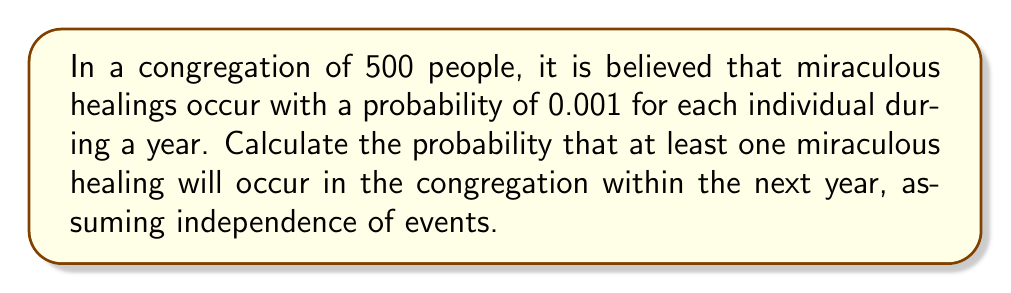Show me your answer to this math problem. Let's approach this step-by-step:

1) First, let's define our events:
   Let A be the event that at least one miraculous healing occurs in the congregation.

2) It's easier to calculate the probability of the complement of A, which is the probability that no miraculous healings occur.

3) For a single person, the probability of not experiencing a miraculous healing is:
   $1 - 0.001 = 0.999$

4) Assuming independence, for all 500 people to not experience a miraculous healing, we multiply this probability 500 times:
   $P(\text{no miracles}) = (0.999)^{500}$

5) Now, we can calculate the probability of at least one miracle occurring:
   $P(A) = 1 - P(\text{no miracles}) = 1 - (0.999)^{500}$

6) Let's calculate this:
   $P(A) = 1 - (0.999)^{500} = 1 - 0.6065 = 0.3935$

7) Convert to a percentage:
   $0.3935 \times 100\% = 39.35\%$

Thus, there is a 39.35% chance that at least one miraculous healing will occur in the congregation within the next year.
Answer: $39.35\%$ 